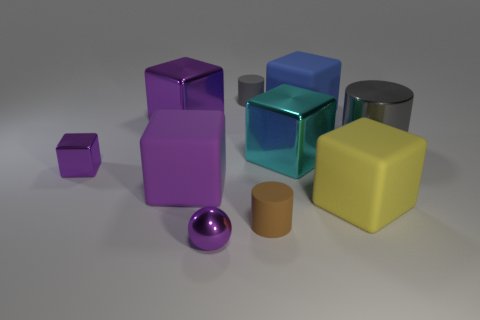Subtract all purple blocks. How many were subtracted if there are1purple blocks left? 2 Subtract all yellow cylinders. How many purple blocks are left? 3 Subtract 1 cylinders. How many cylinders are left? 2 Subtract all large purple cubes. How many cubes are left? 4 Subtract all blue blocks. How many blocks are left? 5 Subtract all brown cubes. Subtract all brown spheres. How many cubes are left? 6 Subtract all spheres. How many objects are left? 9 Add 2 matte blocks. How many matte blocks exist? 5 Subtract 0 brown cubes. How many objects are left? 10 Subtract all cyan metallic cubes. Subtract all big purple metal blocks. How many objects are left? 8 